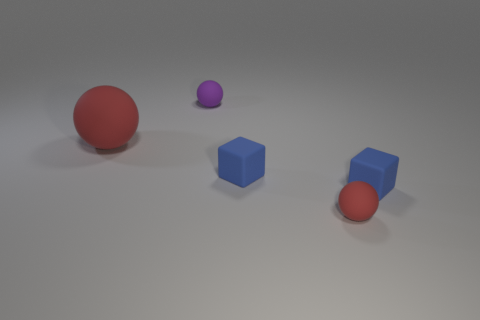Can you describe the arrangement of the objects? Certainly! In the image, we see a large red ball to the left and slightly forward, while a smaller purple ball is to its right and behind. There are also two blue objects, a cube and a cylinder, to the right of the red ball. The tiny blue cylinders are positioned in front of the blue cube, creating a diagonal line of objects from the red ball to the small purple ball. 